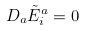<formula> <loc_0><loc_0><loc_500><loc_500>D _ { a } { \tilde { E } } _ { i } ^ { a } = 0</formula> 